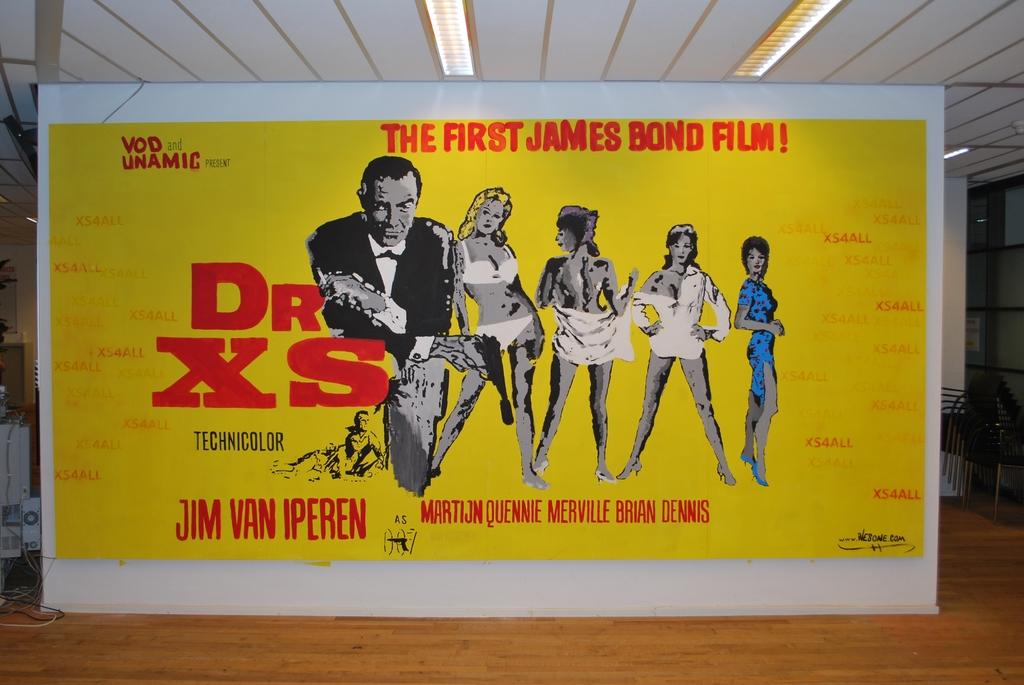What was this the first of?
Your answer should be very brief. James bond film. 